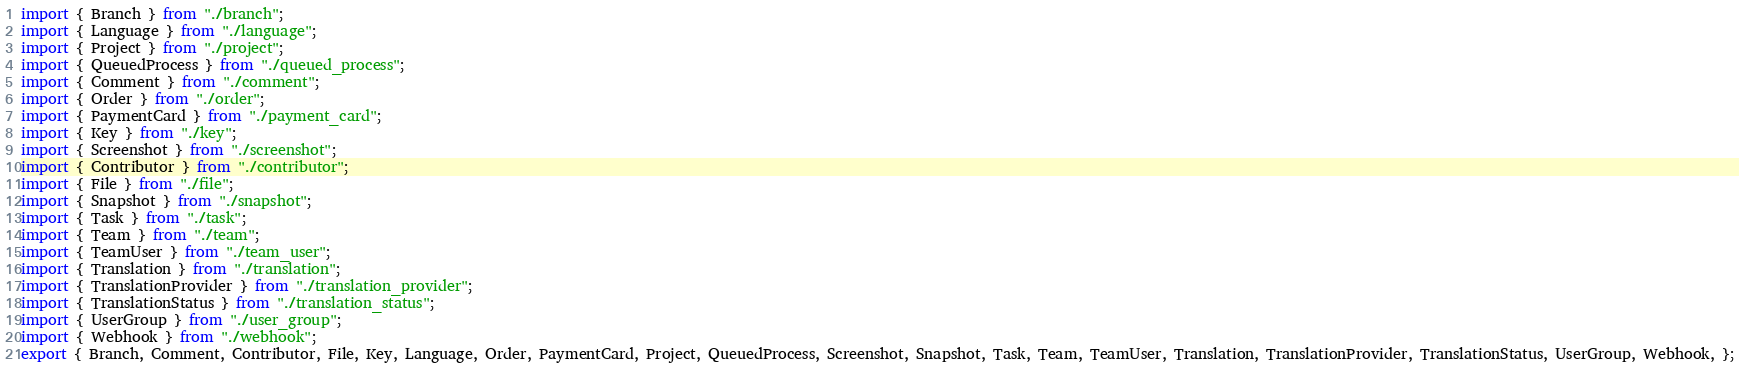Convert code to text. <code><loc_0><loc_0><loc_500><loc_500><_TypeScript_>import { Branch } from "./branch";
import { Language } from "./language";
import { Project } from "./project";
import { QueuedProcess } from "./queued_process";
import { Comment } from "./comment";
import { Order } from "./order";
import { PaymentCard } from "./payment_card";
import { Key } from "./key";
import { Screenshot } from "./screenshot";
import { Contributor } from "./contributor";
import { File } from "./file";
import { Snapshot } from "./snapshot";
import { Task } from "./task";
import { Team } from "./team";
import { TeamUser } from "./team_user";
import { Translation } from "./translation";
import { TranslationProvider } from "./translation_provider";
import { TranslationStatus } from "./translation_status";
import { UserGroup } from "./user_group";
import { Webhook } from "./webhook";
export { Branch, Comment, Contributor, File, Key, Language, Order, PaymentCard, Project, QueuedProcess, Screenshot, Snapshot, Task, Team, TeamUser, Translation, TranslationProvider, TranslationStatus, UserGroup, Webhook, };
</code> 